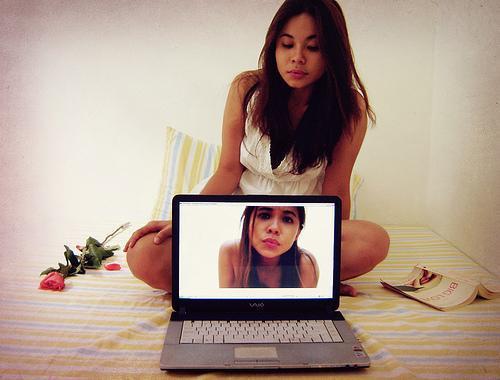How many people are in the picture?
Give a very brief answer. 2. 